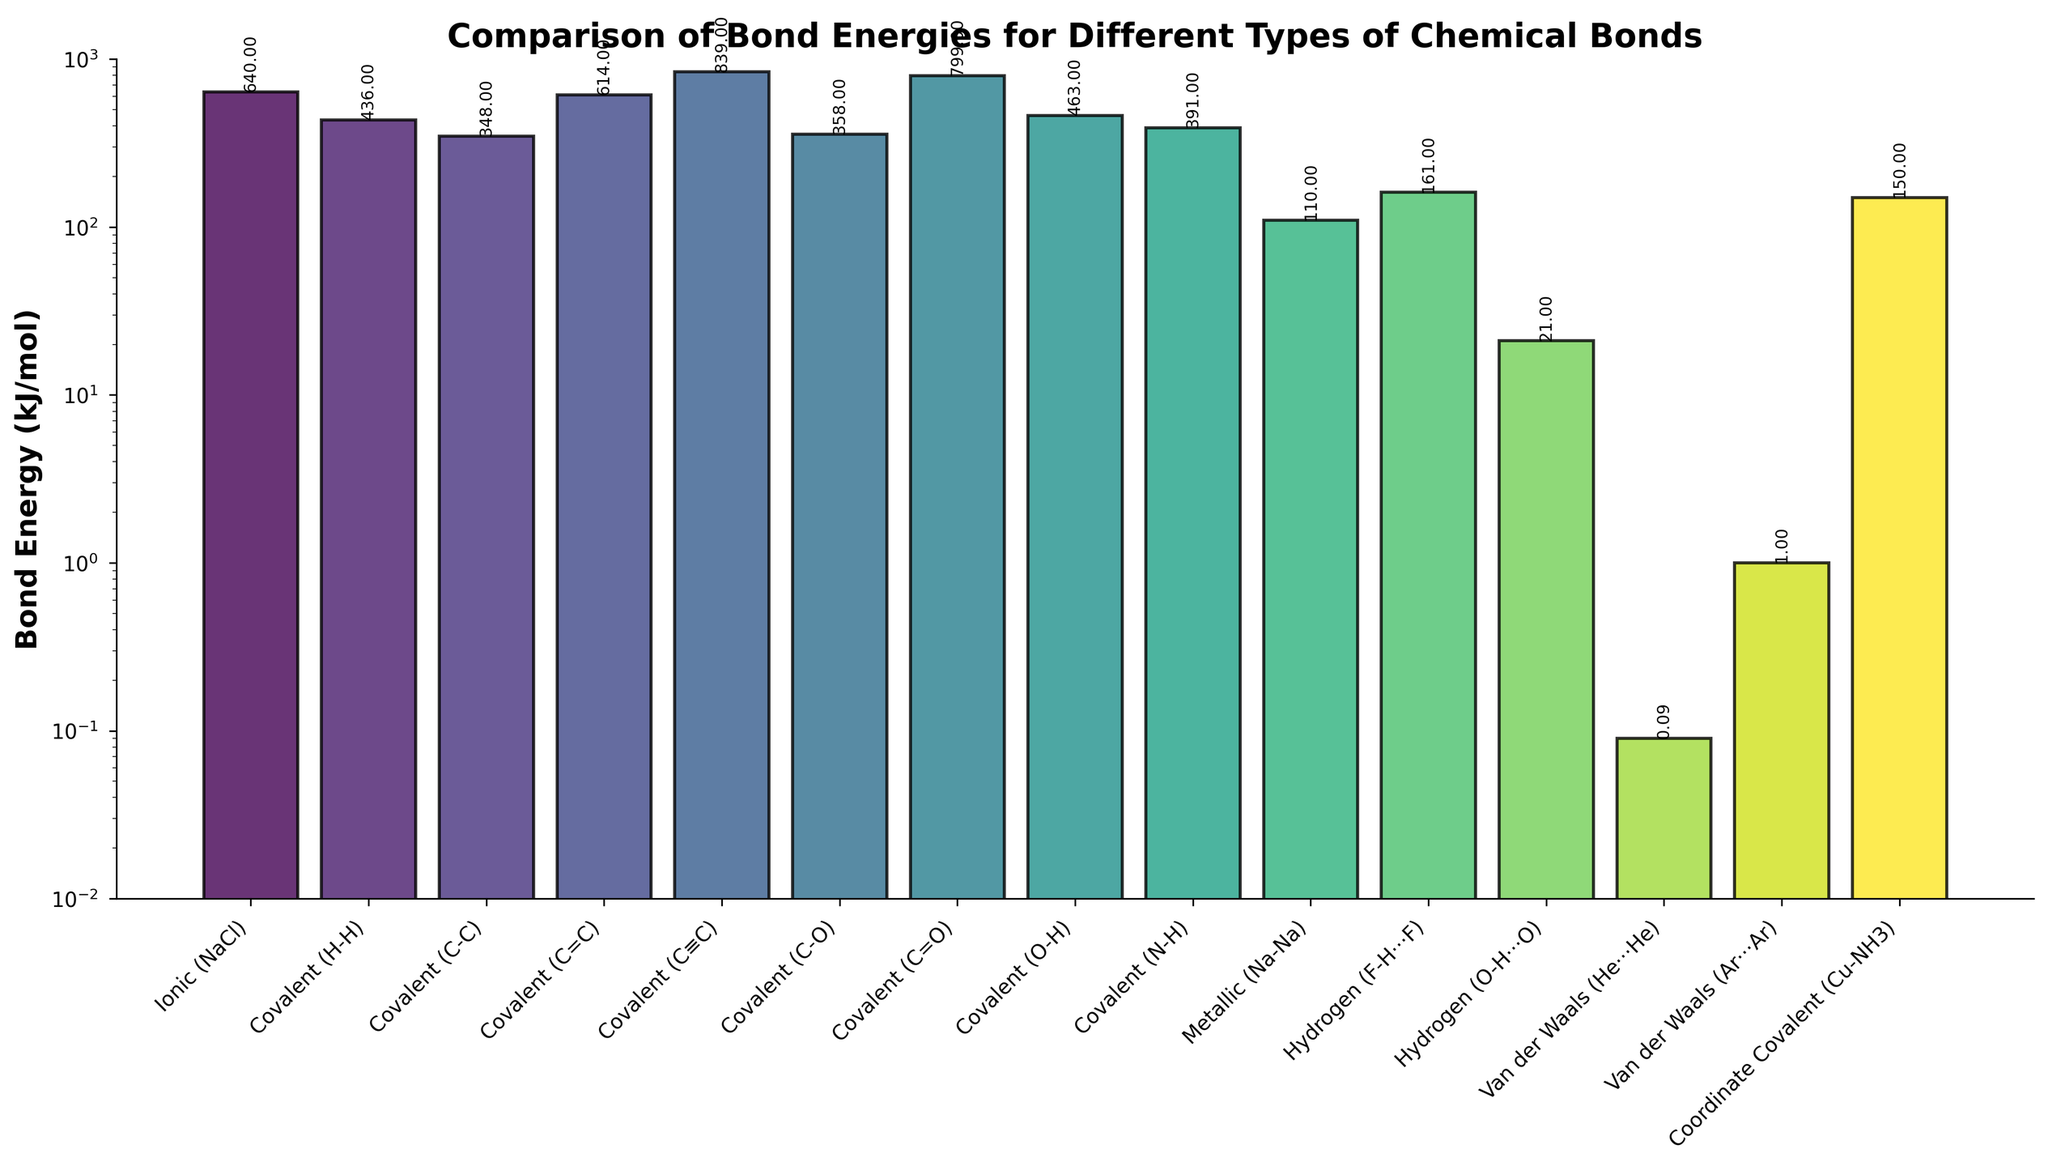What is the bond with the highest energy? Identify the tallest bar in the figure. The bar for Covalent (C≡C) bond, with a bond energy of 839 kJ/mol, is the tallest.
Answer: Covalent (C≡C) Which bond type has the lowest bond energy, and what is its value? Identify the shortest bar in the figure. The bar for Van der Waals (He···He) bond, with a bond energy of 0.09 kJ/mol, is the shortest.
Answer: Van der Waals (He···He), 0.09 kJ/mol What is the difference in bond energy between the highest and lowest energy bonds? Subtract the bond energy of the lowest bond from the highest bond: 839 kJ/mol (Covalent (C≡C)) - 0.09 kJ/mol (Van der Waals (He···He)) = 838.91 kJ/mol.
Answer: 838.91 kJ/mol How does the bond energy of an Ionic (NaCl) bond compare to that of a Covalent (C=O) bond? Compare the heights of the bars for Ionic (NaCl) and Covalent (C=O). The Ionic (NaCl) bond has a bond energy of 640 kJ/mol, and the Covalent (C=O) bond has a bond energy of 799 kJ/mol. The Covalent (C=O) bond energy is higher than the Ionic (NaCl) bond energy.
Answer: Covalent (C=O) > Ionic (NaCl) What is the average bond energy for all Covalent bonds listed? Identify all the Covalent bonds and their energies: H-H (436), C-C (348), C=C (614), C≡C (839), C-O (358), C=O (799), O-H (463), N-H (391). Sum these energies and divide by the number of bonds: (436 + 348 + 614 + 839 + 358 + 799 + 463 + 391) / 8 = 5358 / 8 = 669.75 kJ/mol.
Answer: 669.75 kJ/mol Which bond type has a higher bond energy: Hydrogen bond (F-H···F) or Coordinate Covalent (Cu-NH3)? Compare the heights of the bars for Hydrogen (F-H···F) and Coordinate Covalent (Cu-NH3). The Hydrogen (F-H···F) bond energy is 161 kJ/mol, and the Coordinate Covalent (Cu-NH3) bond energy is 150 kJ/mol. The Hydrogen bond (F-H···F) is higher in energy.
Answer: Hydrogen (F-H···F) List the bonds in order of increasing bond energy. Arrange the bars from shortest to tallest: Van der Waals (He···He), Van der Waals (Ar···Ar), Hydrogen (O-H···O), Coordinate Covalent (Cu-NH3), Hydrogen (F-H···F), Metallic (Na-Na), Covalent (N-H), Covalent (C-C), Covalent (C-O), Covalent (H-H), Covalent (O-H), Ionic (NaCl), Covalent (C=C), Covalent (C=O), Covalent (C≡C).
Answer: Van der Waals (He···He), Van der Waals (Ar···Ar), Hydrogen (O-H···O), Coordinate Covalent (Cu-NH3), Hydrogen (F-H···F), Metallic (Na-Na), Covalent (N-H), Covalent (C-C), Covalent (C-O), Covalent (H-H), Covalent (O-H), Ionic (NaCl), Covalent (C=C), Covalent (C=O), Covalent (C≡C) What is the median bond energy of the dataset? Sort all the bond energies and find the middle value: 0.09, 1.0, 21, 110, 150, 161, 348, 358, 391, 436, 463, 614, 640, 799, 839. The median is the 8th value (in a list of 15): 358 kJ/mol.
Answer: 358 kJ/mol Which bond types have a bond energy value over 500 kJ/mol? Identify the bars/values higher than 500 kJ/mol: Covalent (C≡C) 839, Covalent (C=O) 799, Covalent (C=C) 614, and Ionic (NaCl) 640.
Answer: Covalent (C≡C), Covalent (C=O), Covalent (C=C), Ionic (NaCl) 